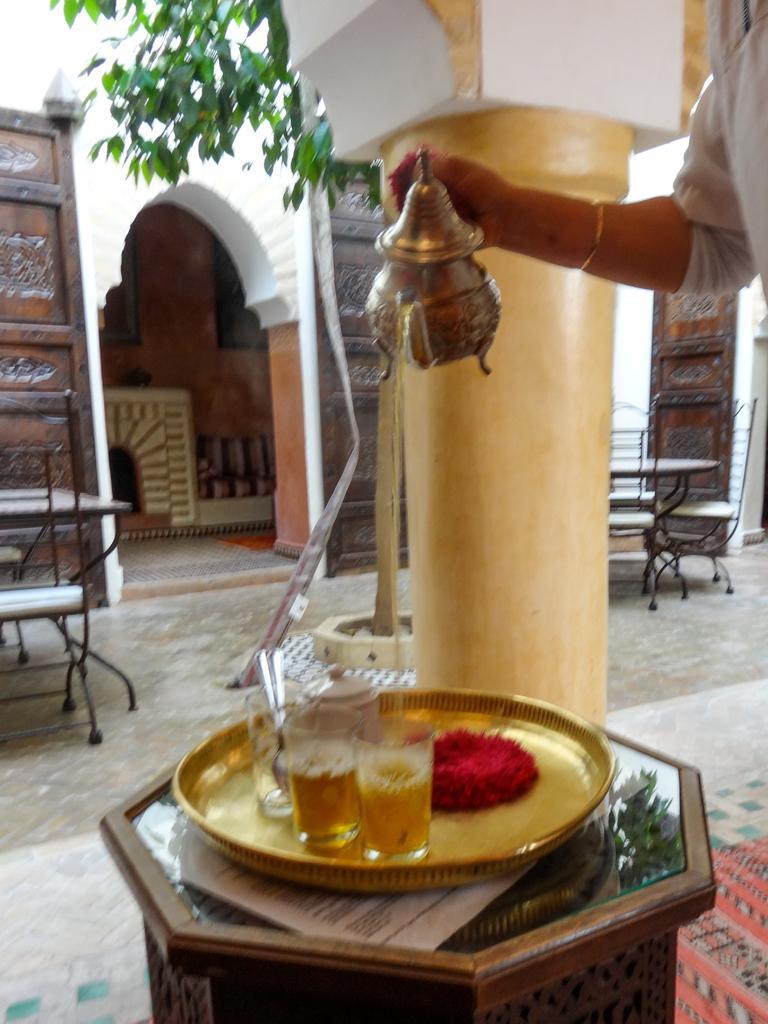Describe this image in one or two sentences. This is the picture inside the room. At the right side of the image there is a person standing and holding the object. There are glasses, spoon, plate, paper on the table. At the back there are tables and chairs and in the middle there is a plant. 